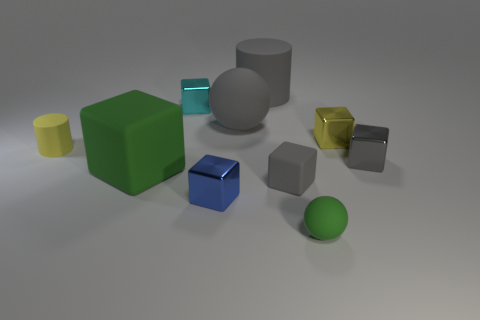Subtract all small matte cubes. How many cubes are left? 5 Subtract all blue cubes. How many cubes are left? 5 Subtract all red cubes. Subtract all cyan cylinders. How many cubes are left? 6 Subtract all cylinders. How many objects are left? 8 Add 3 small cylinders. How many small cylinders are left? 4 Add 5 small gray shiny cubes. How many small gray shiny cubes exist? 6 Subtract 0 green cylinders. How many objects are left? 10 Subtract all yellow cubes. Subtract all tiny rubber objects. How many objects are left? 6 